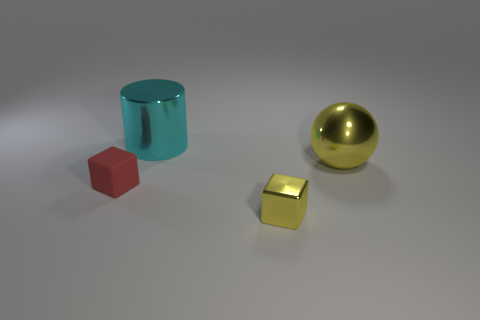What is the material of the sphere that is the same color as the small metallic thing?
Offer a very short reply. Metal. There is a yellow shiny thing that is behind the red cube; does it have the same size as the tiny red thing?
Offer a very short reply. No. There is another tiny object that is the same shape as the tiny yellow metal thing; what is its color?
Give a very brief answer. Red. There is a metal thing that is in front of the small cube that is behind the thing that is in front of the red rubber cube; what shape is it?
Provide a succinct answer. Cube. Do the cyan shiny object and the big yellow metallic object have the same shape?
Ensure brevity in your answer.  No. What shape is the yellow shiny thing that is in front of the large metallic object right of the small metal cube?
Ensure brevity in your answer.  Cube. Are any tiny red shiny things visible?
Your response must be concise. No. There is a tiny object that is to the left of the cube that is in front of the rubber object; what number of tiny shiny cubes are left of it?
Your response must be concise. 0. Is the shape of the tiny metal thing the same as the thing that is to the left of the large cyan cylinder?
Give a very brief answer. Yes. Is the number of matte cubes greater than the number of big things?
Provide a succinct answer. No. 